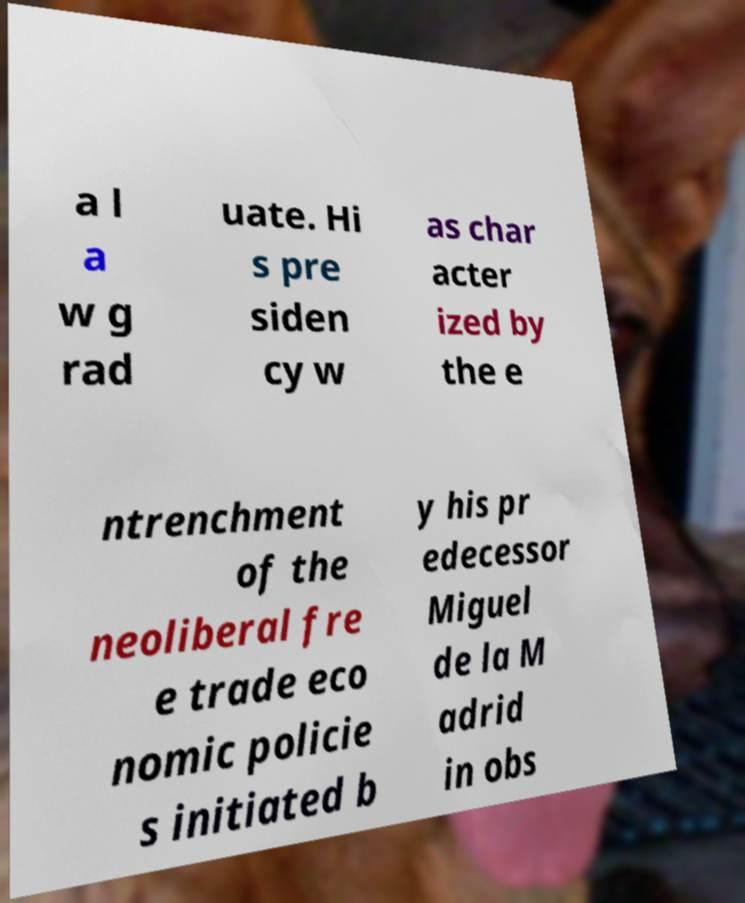Could you assist in decoding the text presented in this image and type it out clearly? a l a w g rad uate. Hi s pre siden cy w as char acter ized by the e ntrenchment of the neoliberal fre e trade eco nomic policie s initiated b y his pr edecessor Miguel de la M adrid in obs 